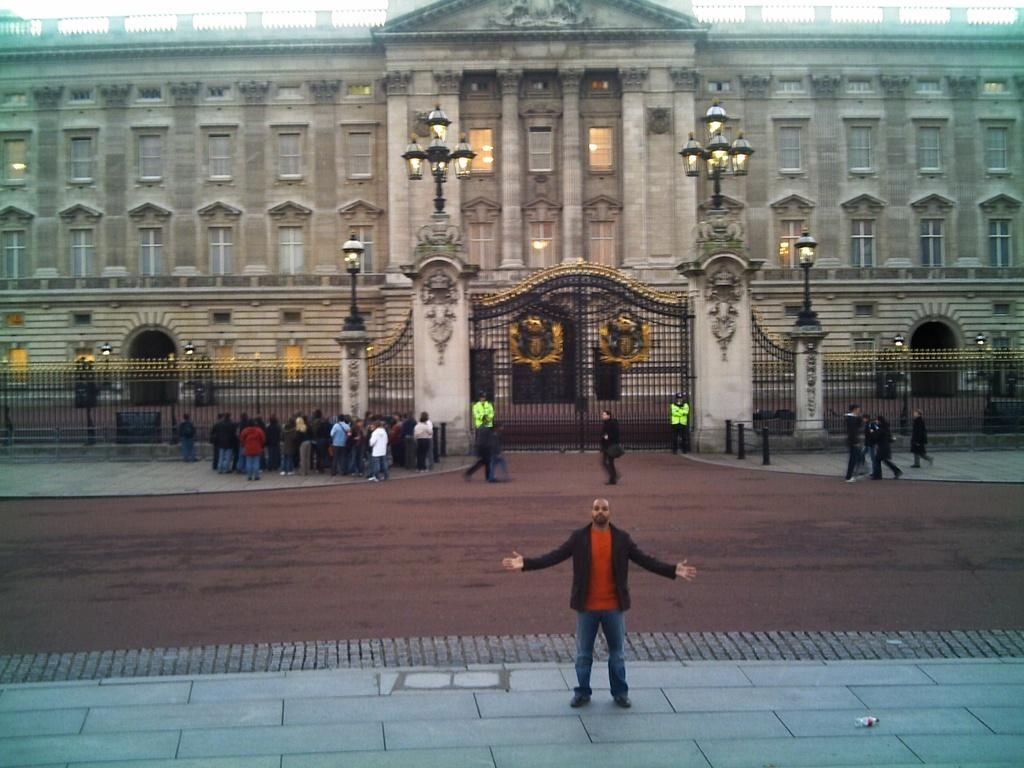What is the main structure in the image? There is a huge building in the image. What is happening in front of the building? Many people are standing in front of the building. Can you describe the action of one person in the image? There is a person standing on a pavement in front of the building, stretching his arms. What type of powder is being used by the person standing on the pavement in the image? There is no powder visible in the image, and the person standing on the pavement is stretching their arms, not using any powder. 